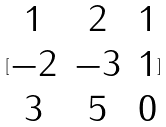<formula> <loc_0><loc_0><loc_500><loc_500>[ \begin{matrix} 1 & 2 & 1 \\ - 2 & - 3 & 1 \\ 3 & 5 & 0 \end{matrix} ]</formula> 